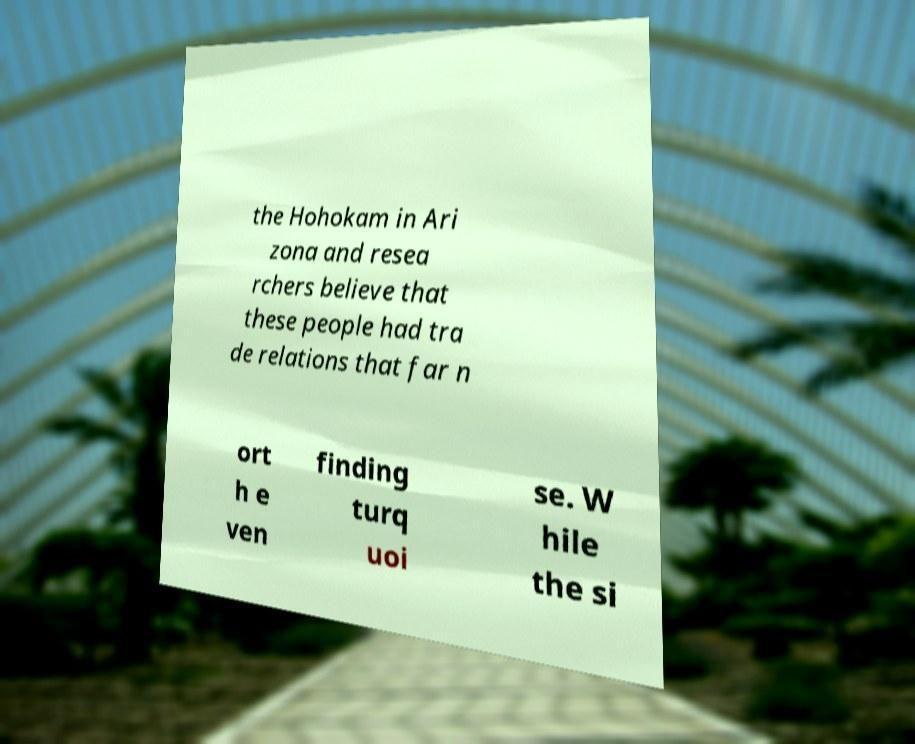Please read and relay the text visible in this image. What does it say? the Hohokam in Ari zona and resea rchers believe that these people had tra de relations that far n ort h e ven finding turq uoi se. W hile the si 